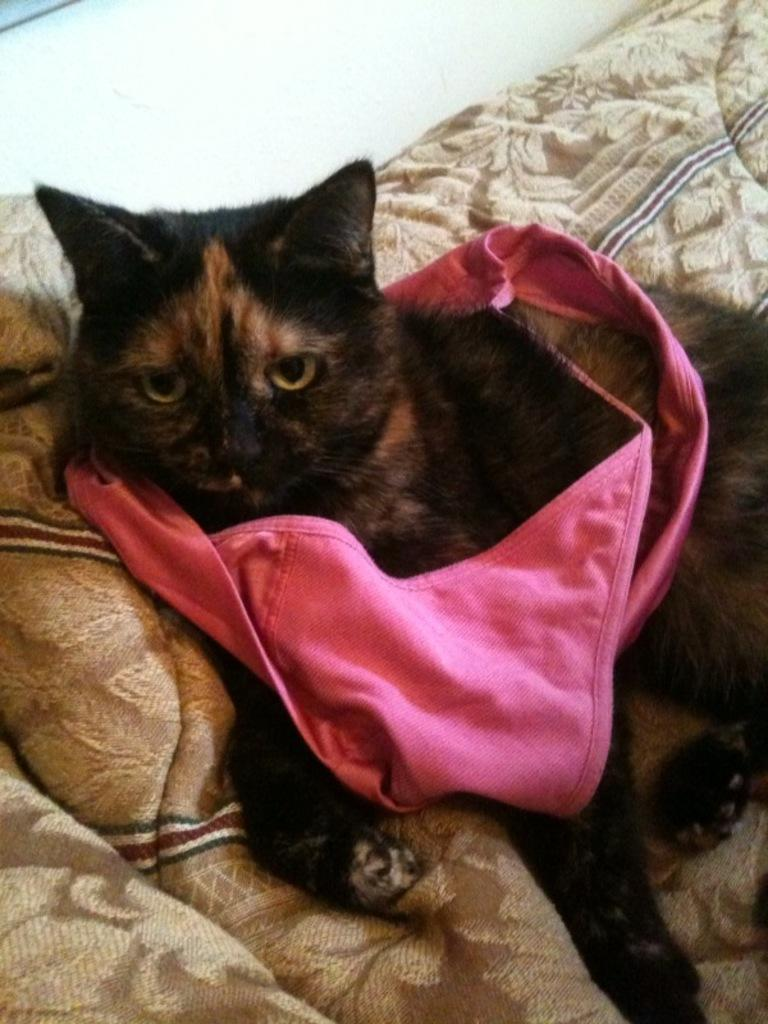What type of animal is in the image? There is a black cat in the image. Is there anything covering the cat? Yes, the cat has a pink cloth on it. Where is the cat located in the image? The cat is lying on a couch. What is the title of the book the cat is reading in the image? There is no book present in the image, and therefore no title to mention. 